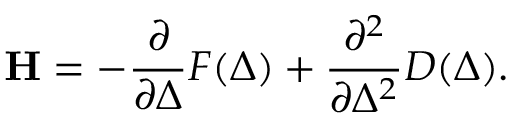<formula> <loc_0><loc_0><loc_500><loc_500>H = - \frac { \partial } { \partial \Delta } F ( \Delta ) + \frac { \partial ^ { 2 } } { \partial \Delta ^ { 2 } } D ( \Delta ) .</formula> 